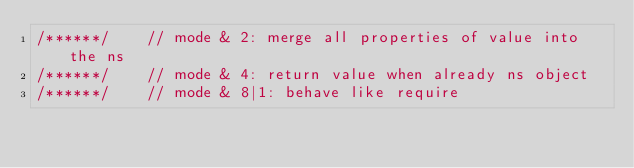Convert code to text. <code><loc_0><loc_0><loc_500><loc_500><_JavaScript_>/******/ 	// mode & 2: merge all properties of value into the ns
/******/ 	// mode & 4: return value when already ns object
/******/ 	// mode & 8|1: behave like require</code> 